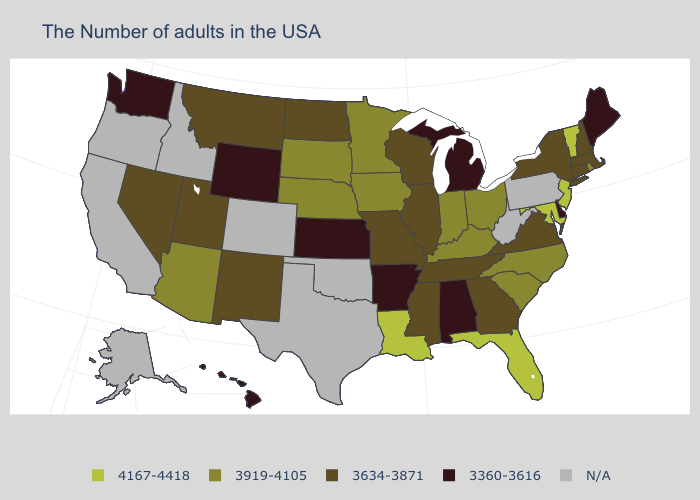What is the value of Wyoming?
Quick response, please. 3360-3616. Name the states that have a value in the range 3360-3616?
Give a very brief answer. Maine, Delaware, Michigan, Alabama, Arkansas, Kansas, Wyoming, Washington, Hawaii. What is the lowest value in states that border Texas?
Keep it brief. 3360-3616. What is the highest value in the MidWest ?
Write a very short answer. 3919-4105. Among the states that border Maine , which have the lowest value?
Quick response, please. New Hampshire. What is the value of Iowa?
Concise answer only. 3919-4105. Which states have the lowest value in the MidWest?
Concise answer only. Michigan, Kansas. Is the legend a continuous bar?
Quick response, please. No. What is the value of New Mexico?
Quick response, please. 3634-3871. What is the value of Maryland?
Concise answer only. 4167-4418. Name the states that have a value in the range 4167-4418?
Answer briefly. Vermont, New Jersey, Maryland, Florida, Louisiana. Name the states that have a value in the range 3919-4105?
Give a very brief answer. Rhode Island, North Carolina, South Carolina, Ohio, Kentucky, Indiana, Minnesota, Iowa, Nebraska, South Dakota, Arizona. How many symbols are there in the legend?
Keep it brief. 5. Which states have the highest value in the USA?
Write a very short answer. Vermont, New Jersey, Maryland, Florida, Louisiana. 